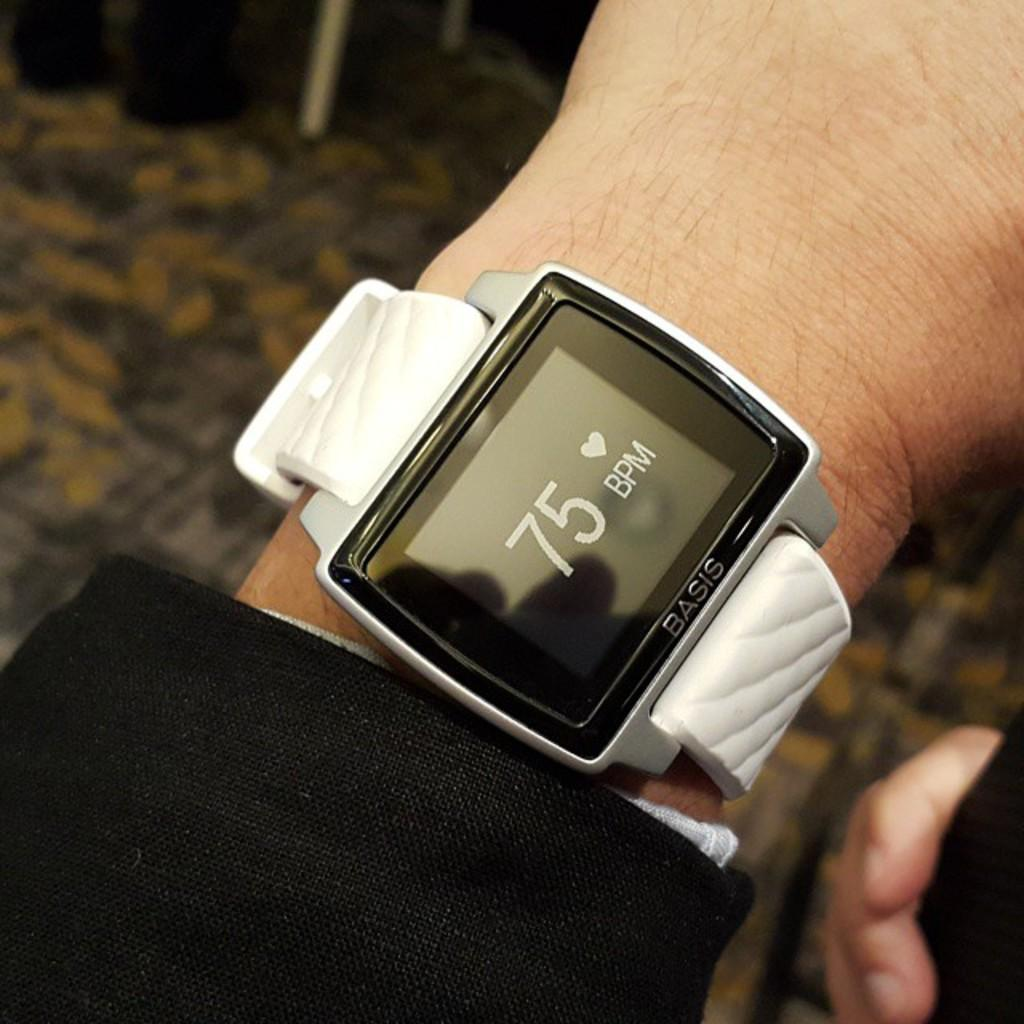<image>
Describe the image concisely. a fitbit with a white band that has 75 BPM on the front. 